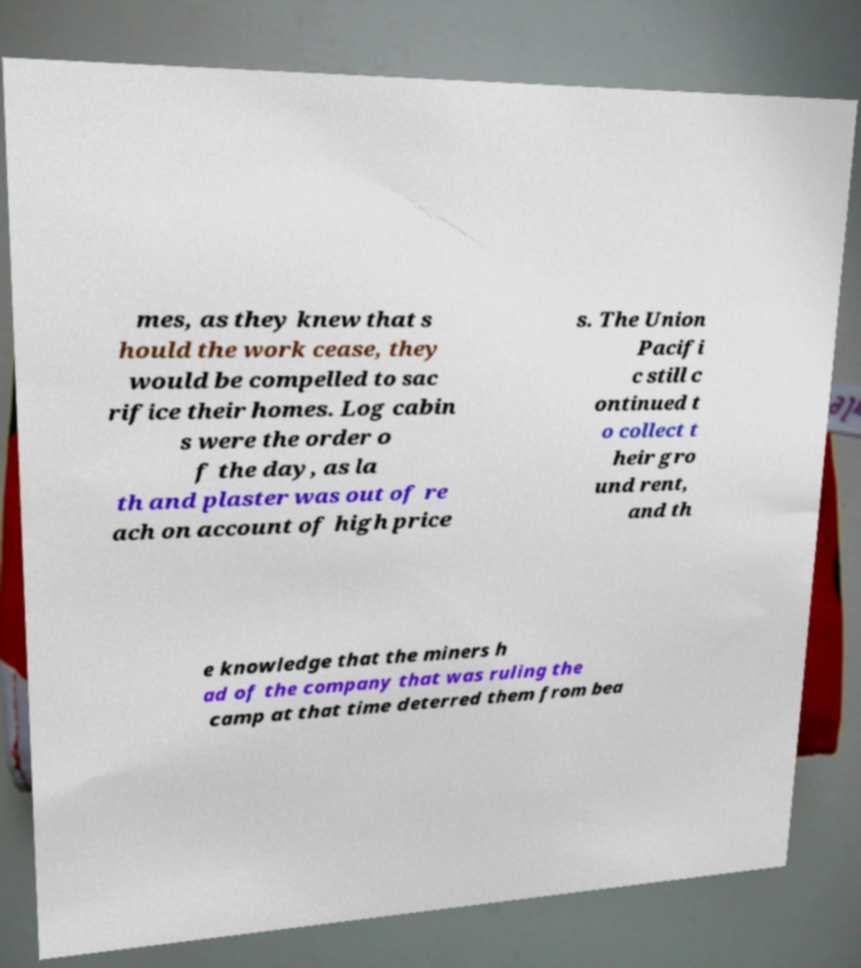I need the written content from this picture converted into text. Can you do that? mes, as they knew that s hould the work cease, they would be compelled to sac rifice their homes. Log cabin s were the order o f the day, as la th and plaster was out of re ach on account of high price s. The Union Pacifi c still c ontinued t o collect t heir gro und rent, and th e knowledge that the miners h ad of the company that was ruling the camp at that time deterred them from bea 